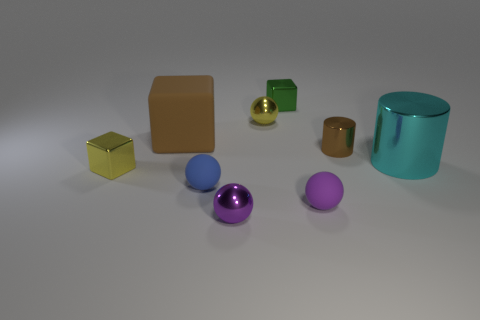Add 1 big cyan cubes. How many objects exist? 10 Subtract all spheres. How many objects are left? 5 Add 9 green shiny objects. How many green shiny objects exist? 10 Subtract 0 cyan blocks. How many objects are left? 9 Subtract all purple matte things. Subtract all metal spheres. How many objects are left? 6 Add 5 spheres. How many spheres are left? 9 